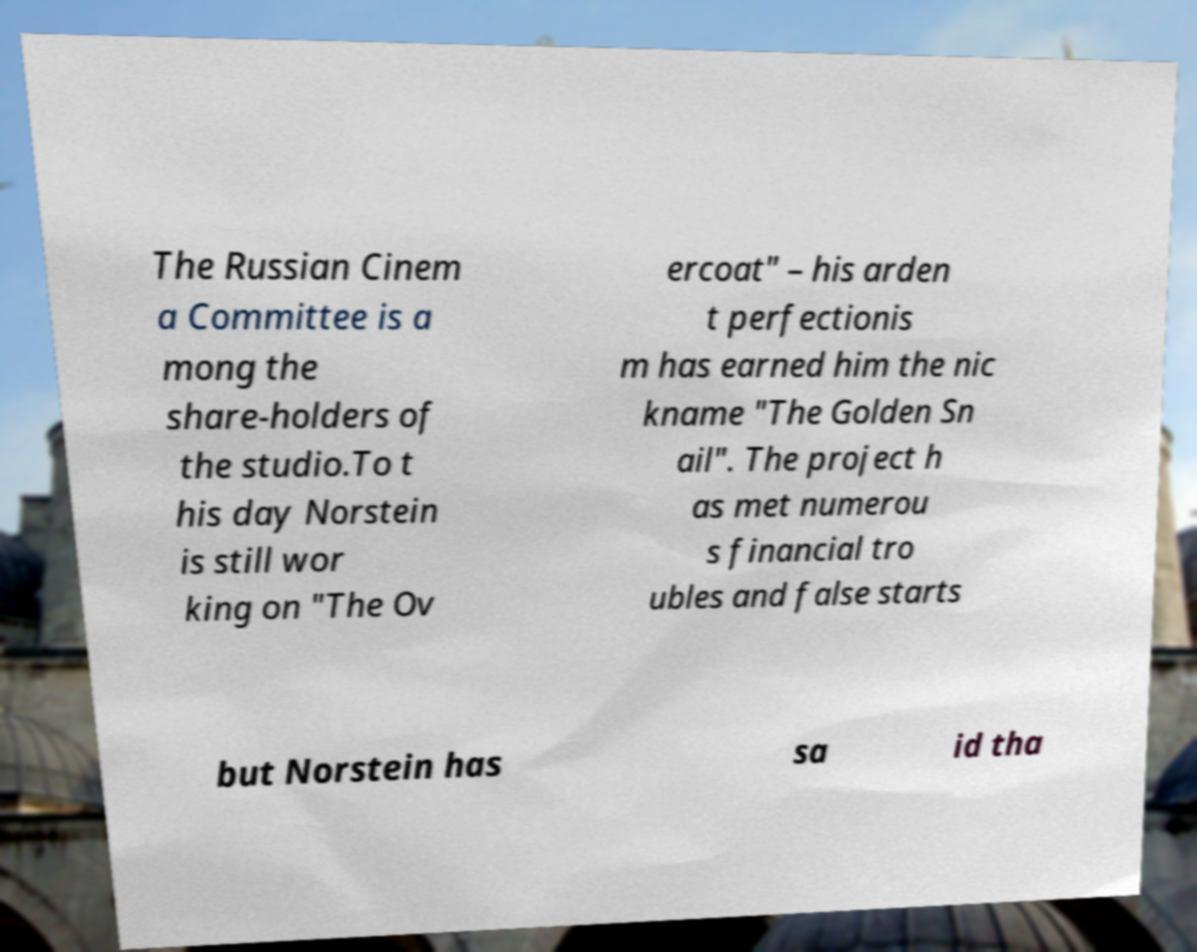Can you accurately transcribe the text from the provided image for me? The Russian Cinem a Committee is a mong the share-holders of the studio.To t his day Norstein is still wor king on "The Ov ercoat" – his arden t perfectionis m has earned him the nic kname "The Golden Sn ail". The project h as met numerou s financial tro ubles and false starts but Norstein has sa id tha 